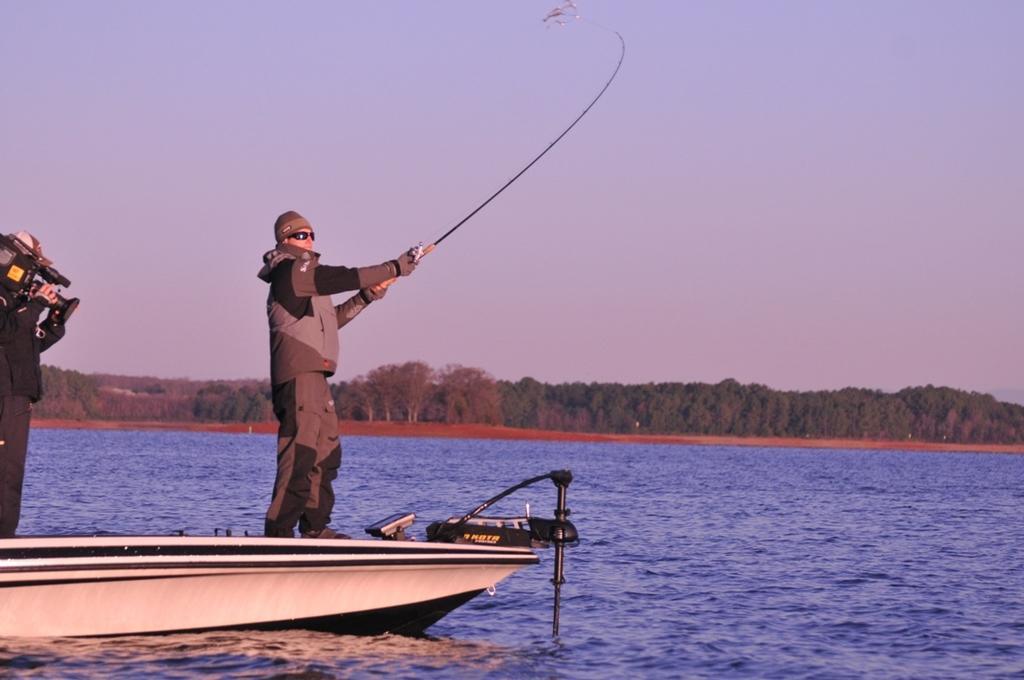How would you summarize this image in a sentence or two? In the image in the center, we can see one boat. On the boat, we can see two persons were standing. And we can see one person is holding a camera and another person is holding a fishing rod. In the background we can see the sky, clouds, trees and water. 